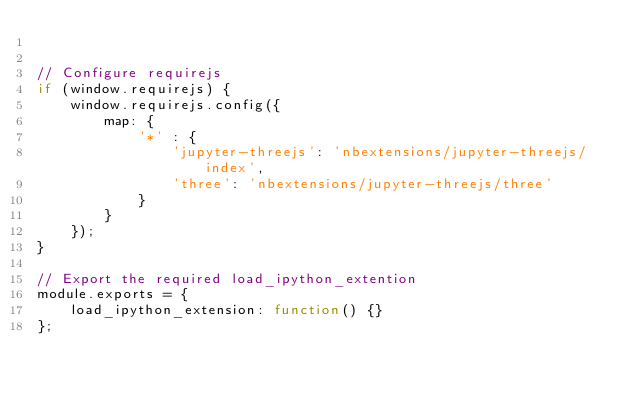Convert code to text. <code><loc_0><loc_0><loc_500><loc_500><_JavaScript_>

// Configure requirejs
if (window.requirejs) {
    window.requirejs.config({
        map: {
            '*' : {
                'jupyter-threejs': 'nbextensions/jupyter-threejs/index',
                'three': 'nbextensions/jupyter-threejs/three'
            }
        }
    });
}

// Export the required load_ipython_extention
module.exports = {
    load_ipython_extension: function() {}
};
</code> 